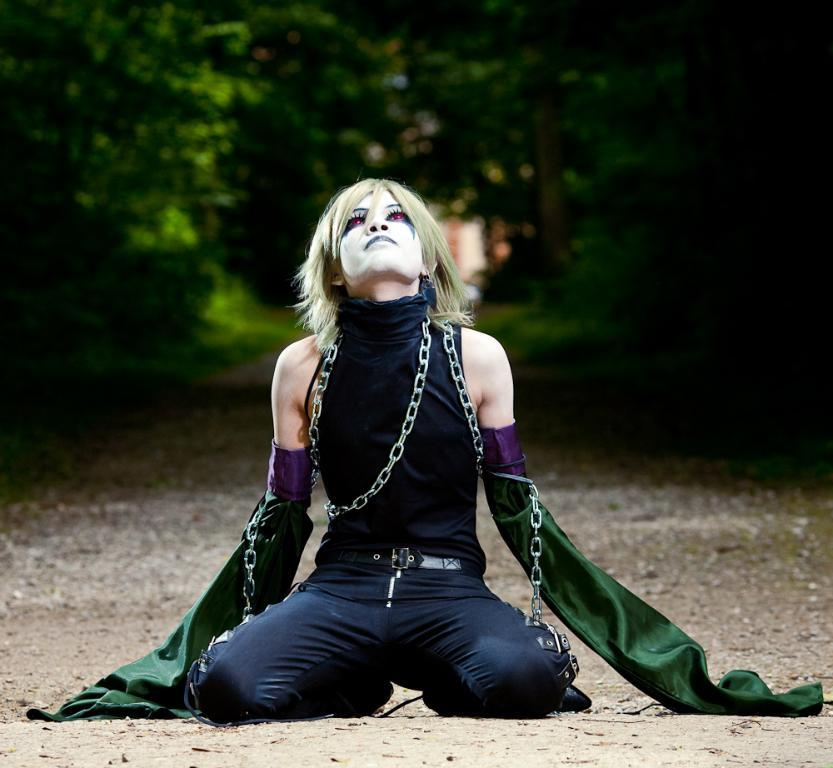Who is the main subject in the image? There is a person in the center of the image. What is the person wearing? The person is wearing a different costume. Can you describe the person's face? There is paint on the person's face. How would you describe the background of the image? The background of the image is blurred. How many girls are participating in the feast in the image? There is no feast or girls present in the image; it features a person with a painted face and a blurred background. 